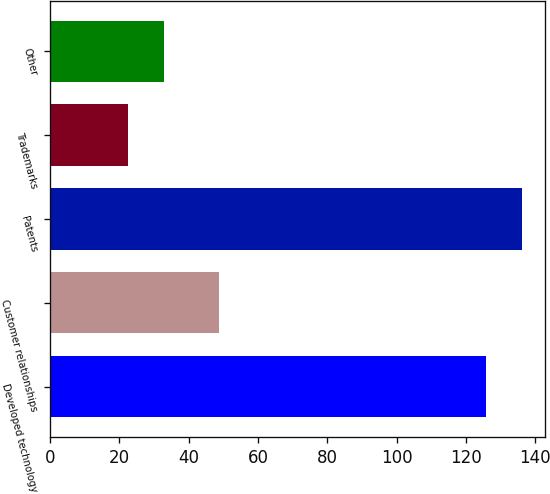<chart> <loc_0><loc_0><loc_500><loc_500><bar_chart><fcel>Developed technology<fcel>Customer relationships<fcel>Patents<fcel>Trademarks<fcel>Other<nl><fcel>125.7<fcel>48.8<fcel>136.2<fcel>22.4<fcel>32.9<nl></chart> 